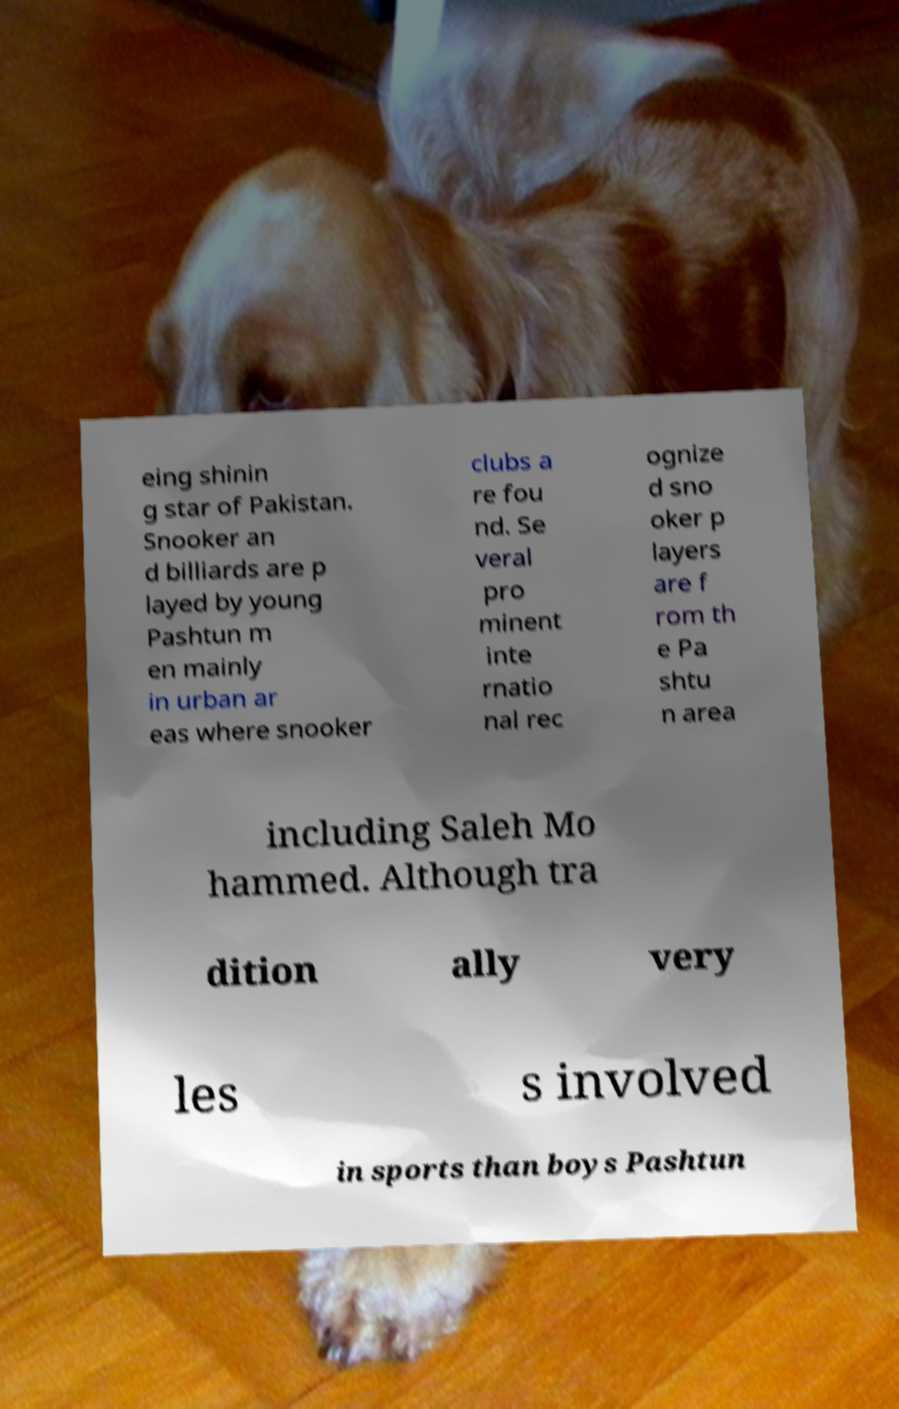Can you accurately transcribe the text from the provided image for me? eing shinin g star of Pakistan. Snooker an d billiards are p layed by young Pashtun m en mainly in urban ar eas where snooker clubs a re fou nd. Se veral pro minent inte rnatio nal rec ognize d sno oker p layers are f rom th e Pa shtu n area including Saleh Mo hammed. Although tra dition ally very les s involved in sports than boys Pashtun 